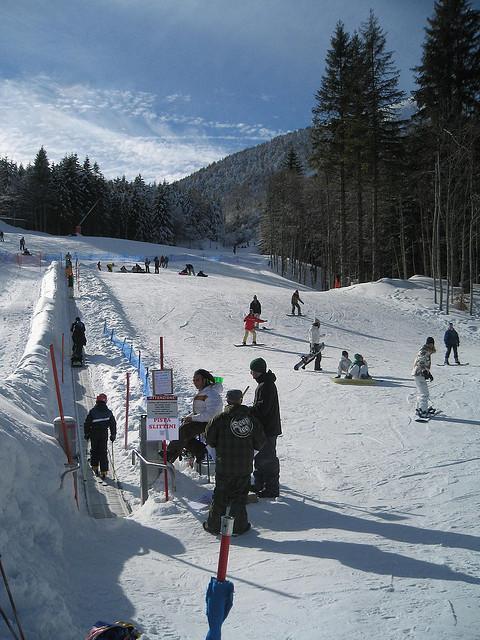How many people are there?
Give a very brief answer. 3. How many train cars are orange?
Give a very brief answer. 0. 